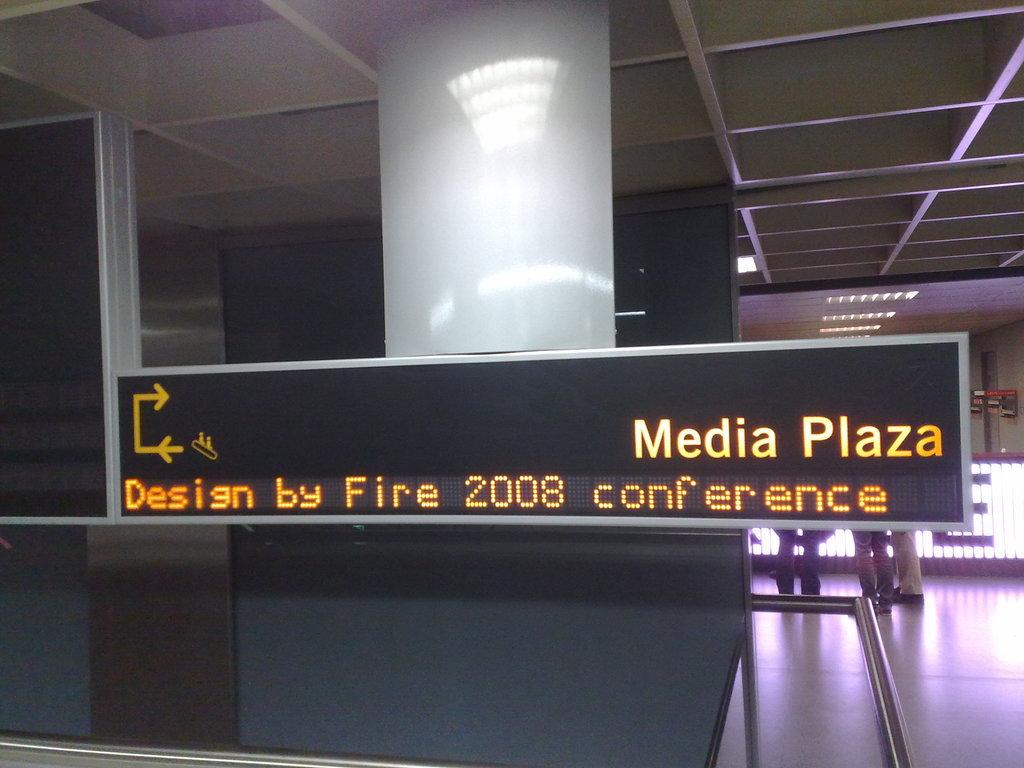Provide a one-sentence caption for the provided image. A sign for Media Plaza and the Design by Fire 2008 conference. 